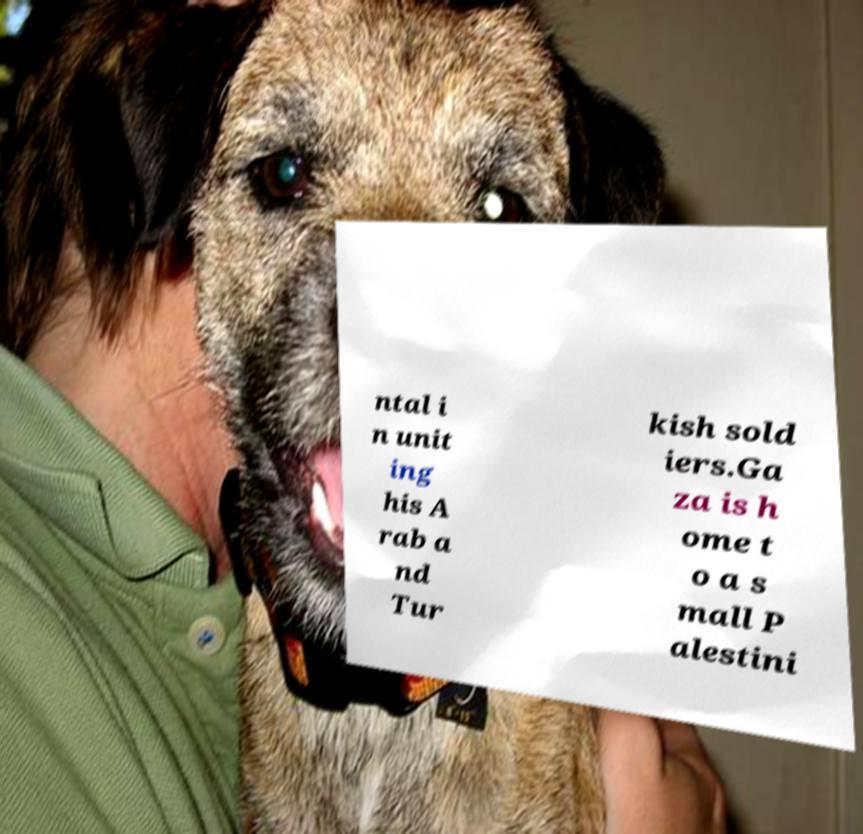I need the written content from this picture converted into text. Can you do that? ntal i n unit ing his A rab a nd Tur kish sold iers.Ga za is h ome t o a s mall P alestini 